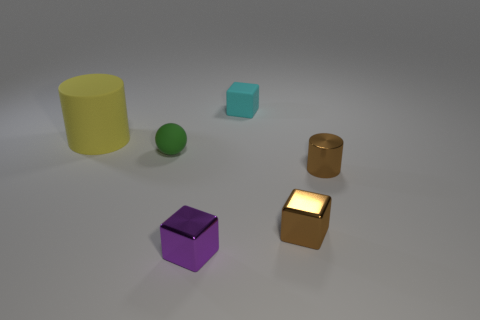Which object seems out of place based on lighting and texture? The small golden cube stands out due to its luminous surface that appears to emit light, contrasting with the matte textures of the other objects. Its glow distinguishes it in terms of lighting and texture, suggesting it may have different properties or significance in the image. 